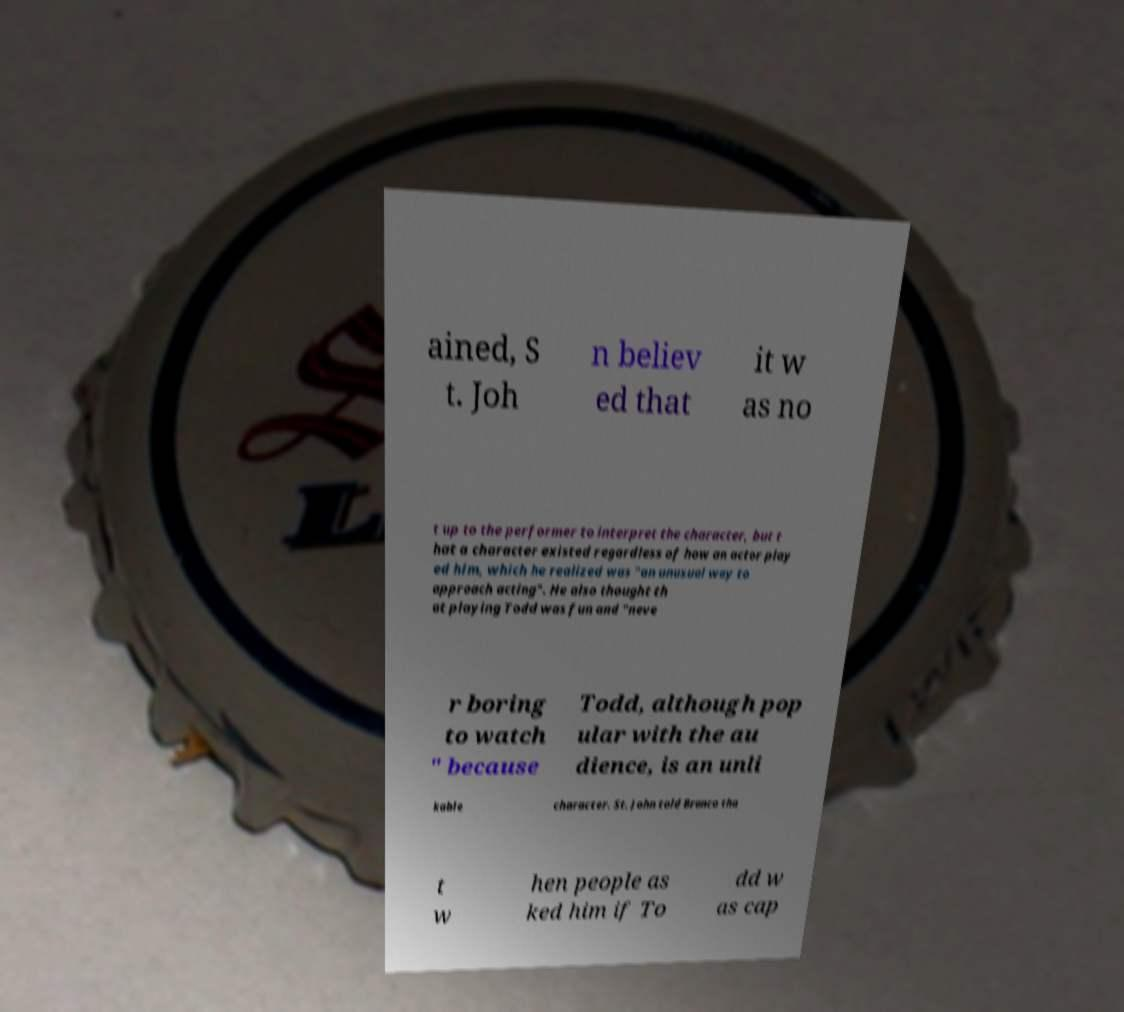Could you extract and type out the text from this image? ained, S t. Joh n believ ed that it w as no t up to the performer to interpret the character, but t hat a character existed regardless of how an actor play ed him, which he realized was "an unusual way to approach acting". He also thought th at playing Todd was fun and "neve r boring to watch " because Todd, although pop ular with the au dience, is an unli kable character. St. John told Branco tha t w hen people as ked him if To dd w as cap 